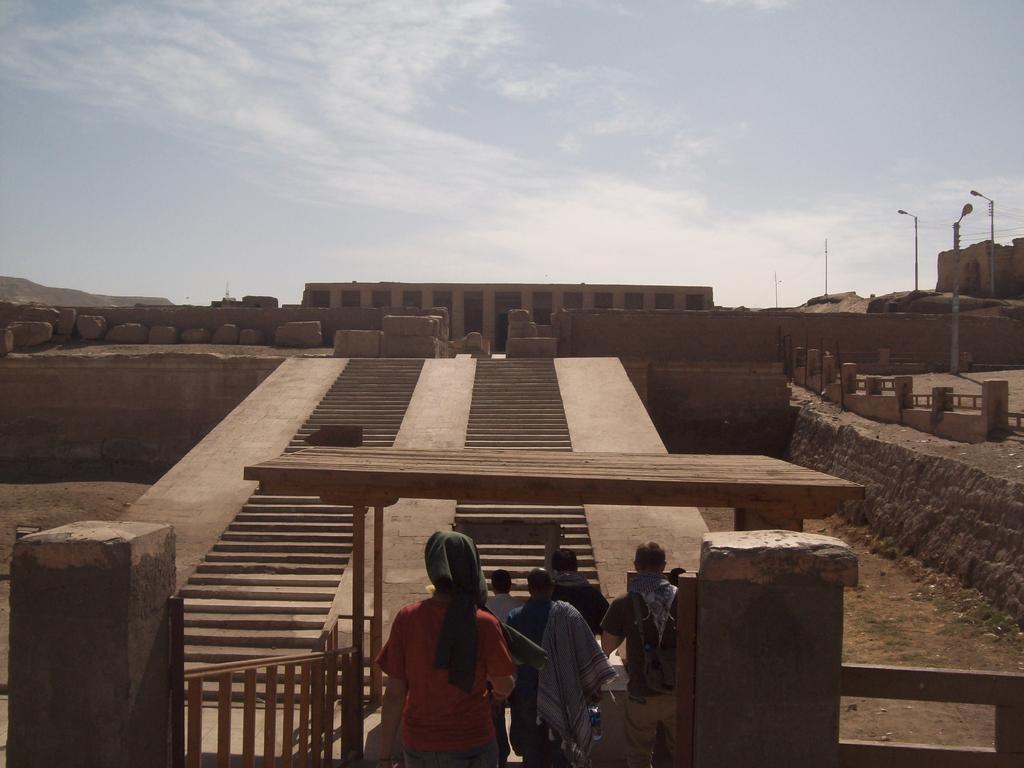How would you summarize this image in a sentence or two? In the background we can see the sky and a fort. In this picture we can see the people, rocks and wooden objects. 